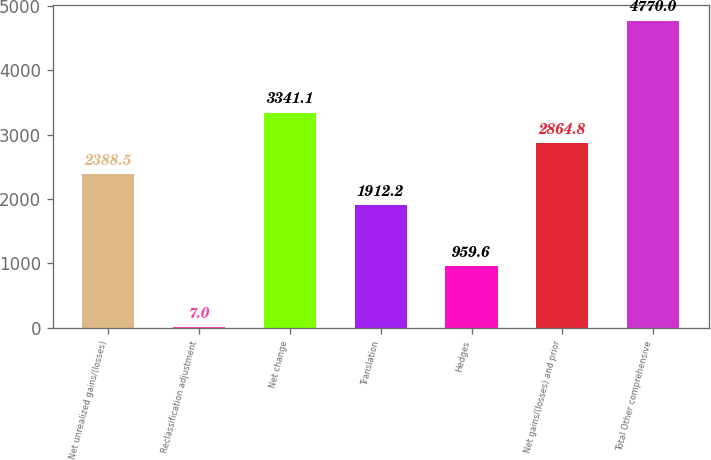Convert chart. <chart><loc_0><loc_0><loc_500><loc_500><bar_chart><fcel>Net unrealized gains/(losses)<fcel>Reclassification adjustment<fcel>Net change<fcel>Translation<fcel>Hedges<fcel>Net gains/(losses) and prior<fcel>Total Other comprehensive<nl><fcel>2388.5<fcel>7<fcel>3341.1<fcel>1912.2<fcel>959.6<fcel>2864.8<fcel>4770<nl></chart> 